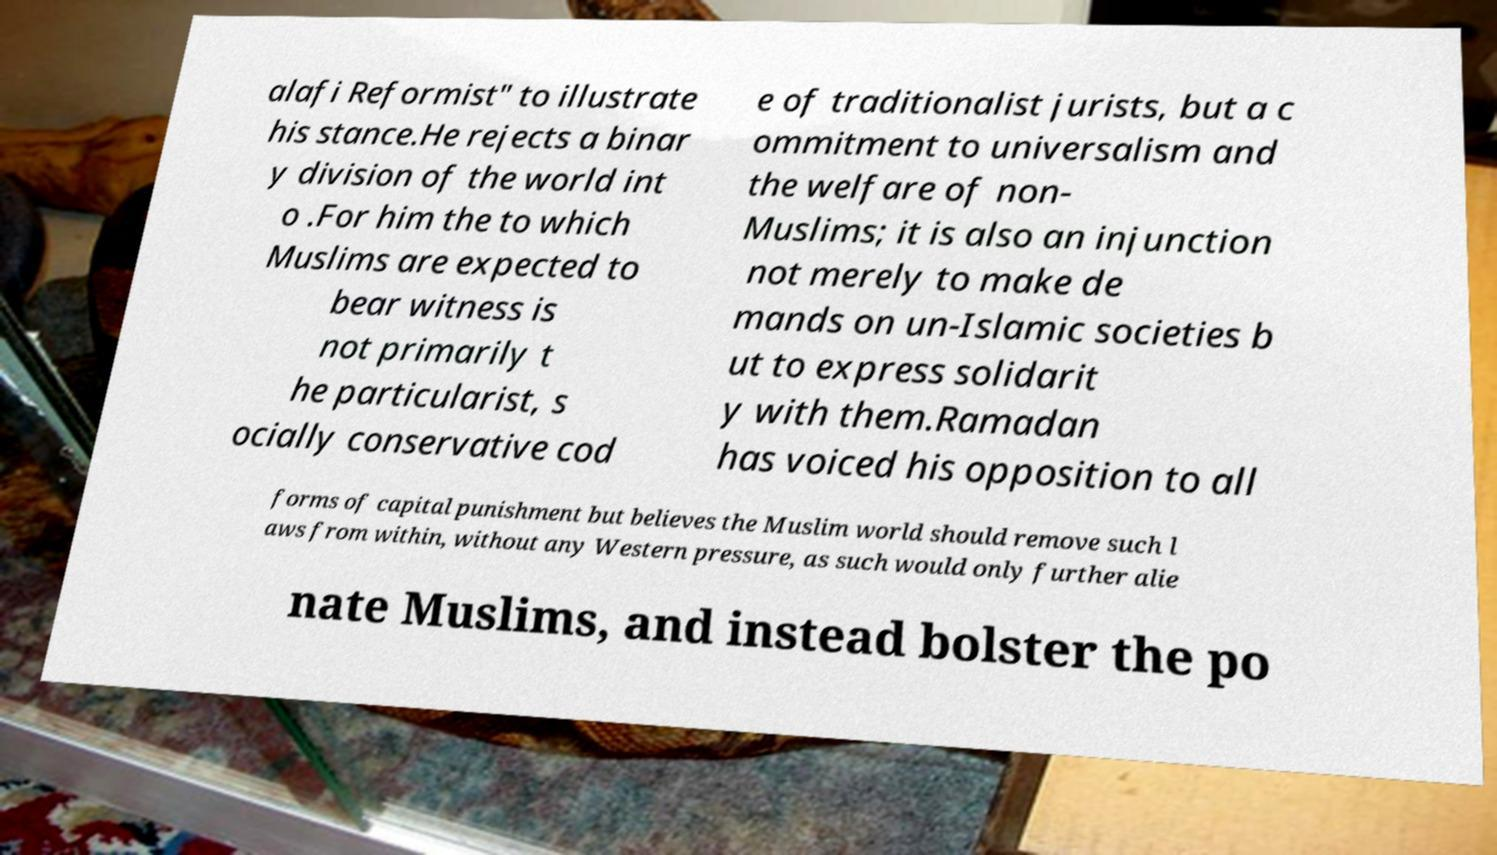I need the written content from this picture converted into text. Can you do that? alafi Reformist" to illustrate his stance.He rejects a binar y division of the world int o .For him the to which Muslims are expected to bear witness is not primarily t he particularist, s ocially conservative cod e of traditionalist jurists, but a c ommitment to universalism and the welfare of non- Muslims; it is also an injunction not merely to make de mands on un-Islamic societies b ut to express solidarit y with them.Ramadan has voiced his opposition to all forms of capital punishment but believes the Muslim world should remove such l aws from within, without any Western pressure, as such would only further alie nate Muslims, and instead bolster the po 